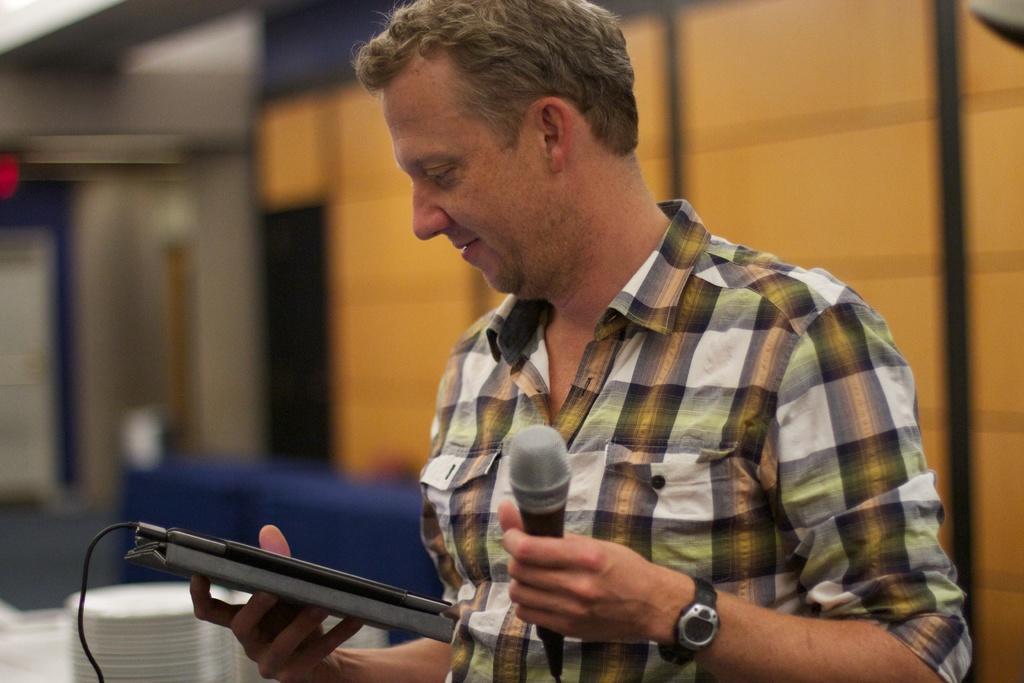Could you give a brief overview of what you see in this image? In this image there is a person wearing checked shirt holding microphone on his left hand and some electronic gadget on right hand. 